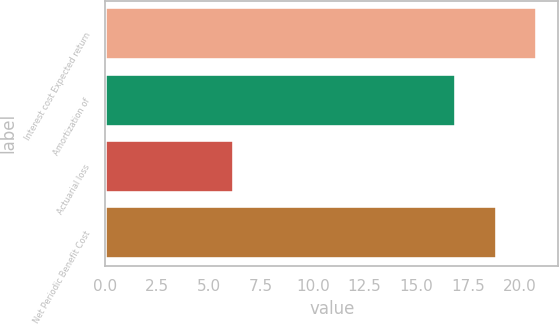Convert chart to OTSL. <chart><loc_0><loc_0><loc_500><loc_500><bar_chart><fcel>Interest cost Expected return<fcel>Amortization of<fcel>Actuarial loss<fcel>Net Periodic Benefit Cost<nl><fcel>20.8<fcel>16.9<fcel>6.2<fcel>18.9<nl></chart> 